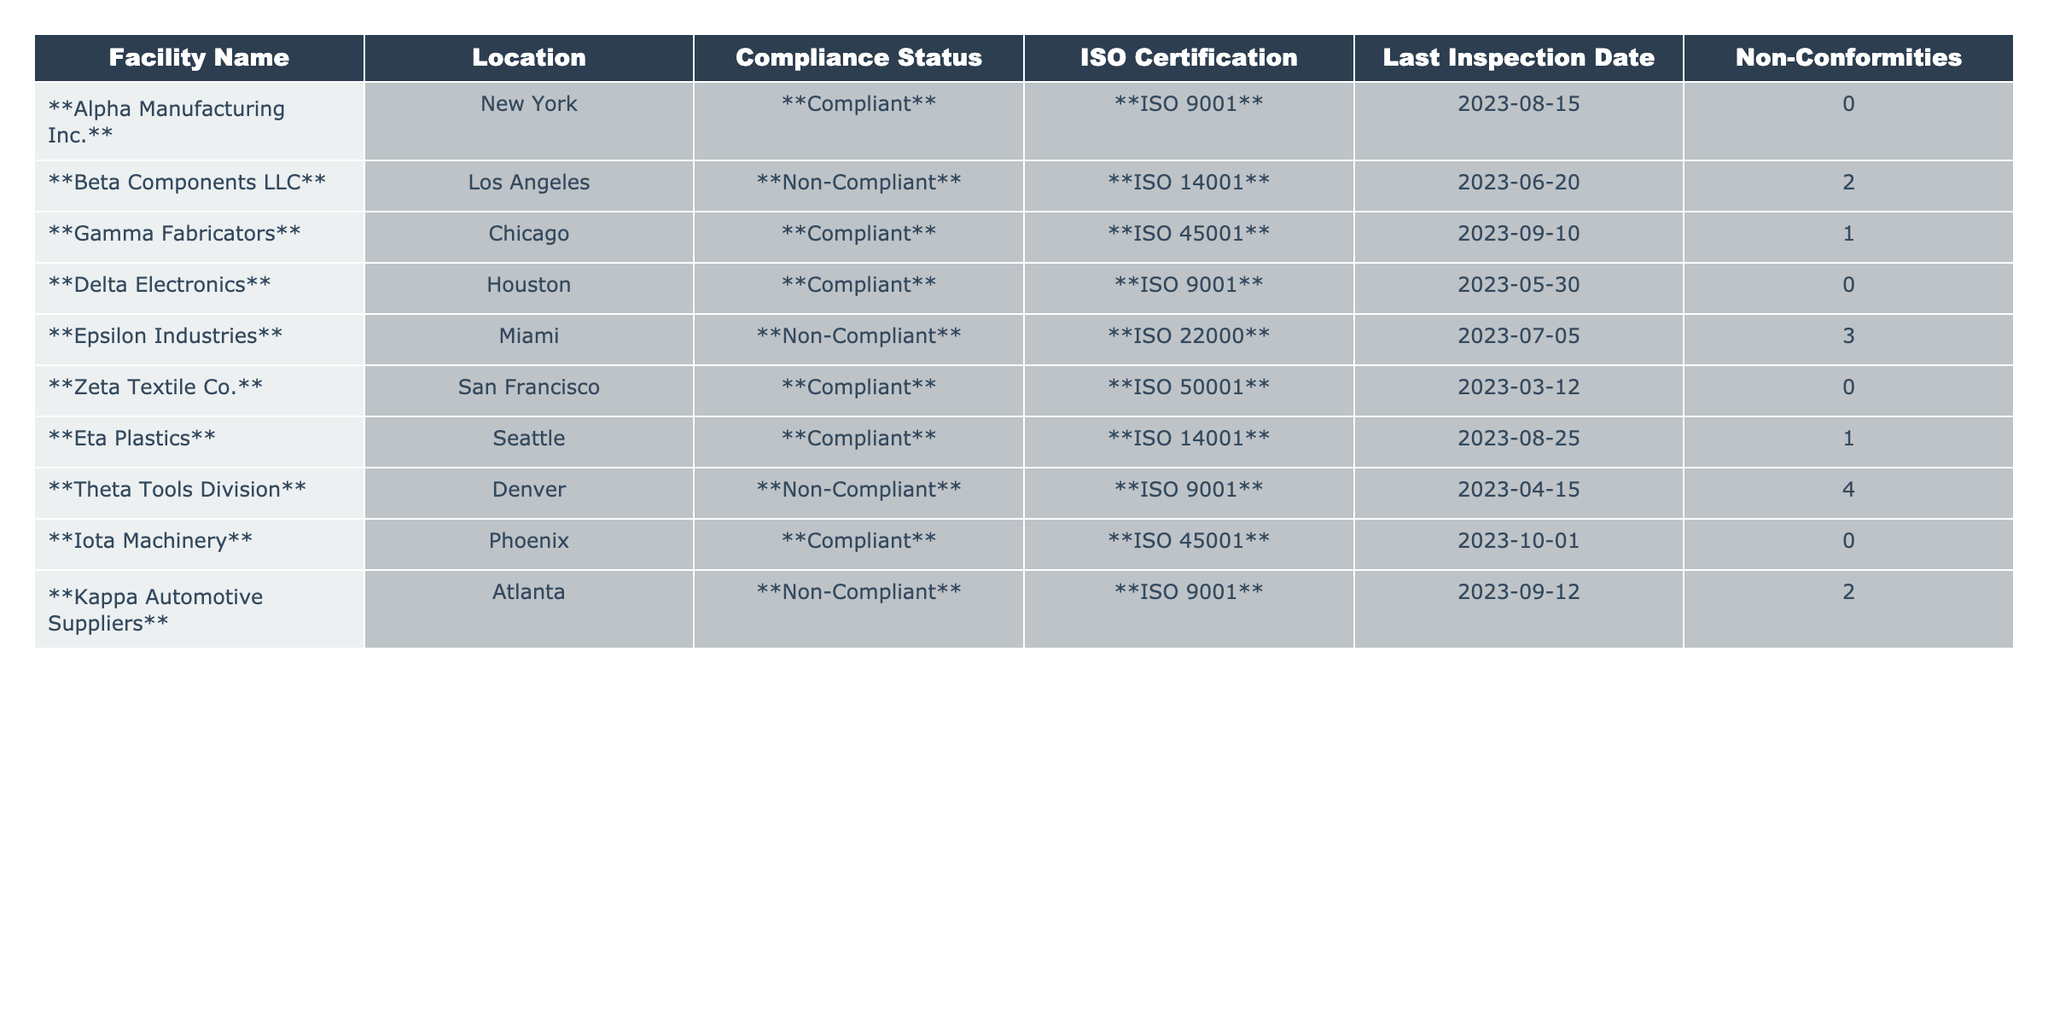What is the Compliance Status of Alpha Manufacturing Inc.? The table shows that Alpha Manufacturing Inc. has a Compliance Status listed as **Compliant**.
Answer: Compliant How many Non-Conformities does Epsilon Industries have? Epsilon Industries has 3 Non-Conformities listed in the table.
Answer: 3 Which facility has the most Non-Conformities? By examining the Non-Conformities column, Epsilon Industries has the highest number with 3, while Theta Tools Division has 4.
Answer: Theta Tools Division Is Delta Electronics ISO certified? The table indicates that Delta Electronics is certified under ISO 9001, confirming it is indeed ISO certified.
Answer: Yes Count the total number of facilities that are Non-Compliant. There are 5 facilities listed as Non-Compliant: Beta Components LLC, Epsilon Industries, Theta Tools Division, and Kappa Automotive Suppliers. Counting them gives a total of 4.
Answer: 4 What is the most recent inspection date for Gamma Fabricators? According to the table, Gamma Fabricators had its last inspection on 2023-09-10, which is the most recent inspection date listed.
Answer: 2023-09-10 How many facilities have ISO 14001 Certification? There are 2 facilities with ISO 14001 Certification: Beta Components LLC and Eta Plastics.
Answer: 2 Are there any compliant facilities with zero Non-Conformities? Yes, both Alpha Manufacturing Inc. and Delta Electronics are compliant facilities that have zero Non-Conformities.
Answer: Yes What is the average number of Non-Conformities among compliant facilities? The compliant facilities are Alpha Manufacturing Inc. (0), Gamma Fabricators (1), Delta Electronics (0), Zeta Textile Co. (0), Eta Plastics (1), and Iota Machinery (0). Summing these gives 2, and dividing by 6 gives an average of 0.33.
Answer: 0.33 Which facility is located in Phoenix? The facility located in Phoenix is Iota Machinery according to the Location column in the table.
Answer: Iota Machinery What is the count of facilities inspected after June 2023? The facilities inspected after June 2023 are Gamma Fabricators (2023-09-10), Iota Machinery (2023-10-01), and Kappa Automotive Suppliers (2023-09-12). That totals 3 facilities.
Answer: 3 Are there any facilities that are compliant but have Non-Conformities? Yes, Gamma Fabricators and Eta Plastics are both compliant but have 1 Non-Conformity each.
Answer: Yes 